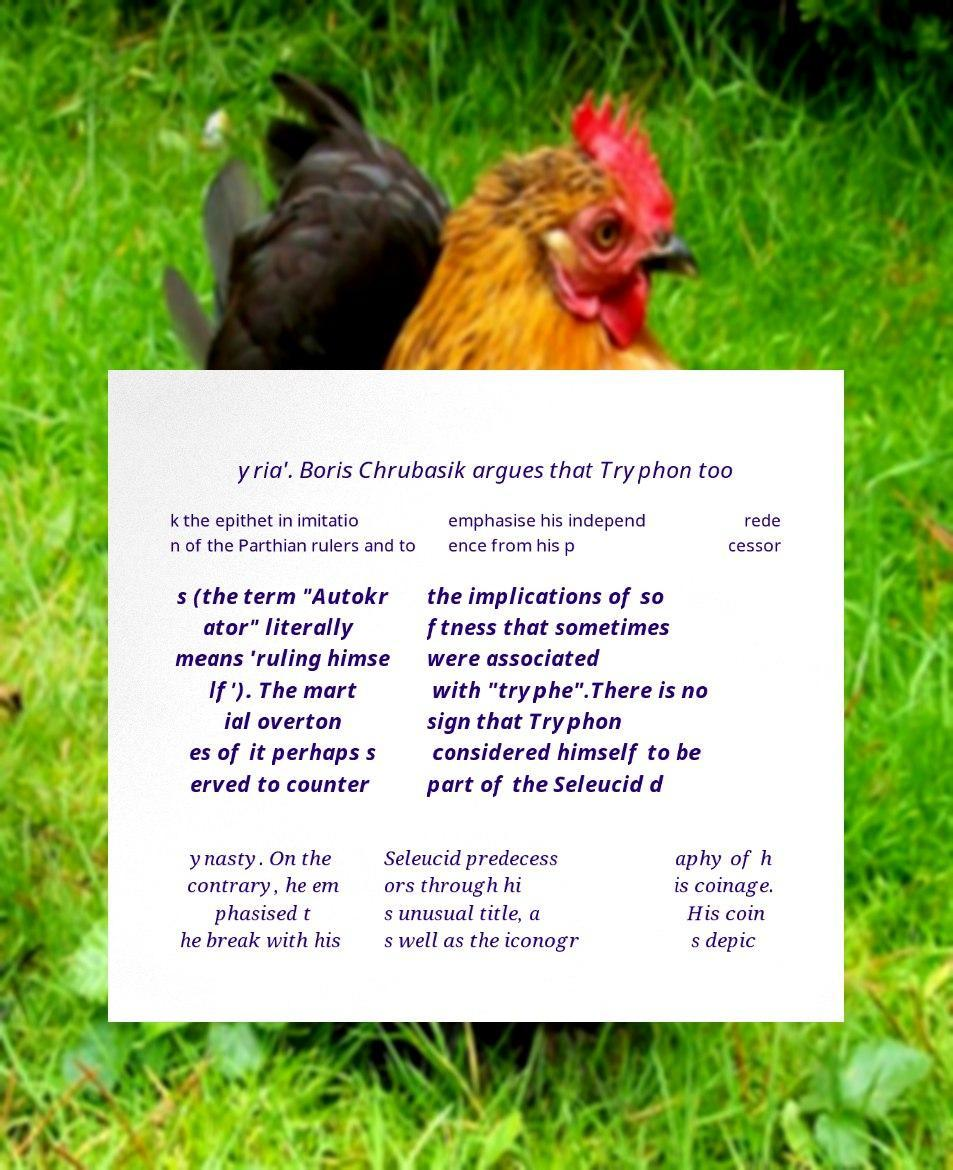Please identify and transcribe the text found in this image. yria'. Boris Chrubasik argues that Tryphon too k the epithet in imitatio n of the Parthian rulers and to emphasise his independ ence from his p rede cessor s (the term "Autokr ator" literally means 'ruling himse lf'). The mart ial overton es of it perhaps s erved to counter the implications of so ftness that sometimes were associated with "tryphe".There is no sign that Tryphon considered himself to be part of the Seleucid d ynasty. On the contrary, he em phasised t he break with his Seleucid predecess ors through hi s unusual title, a s well as the iconogr aphy of h is coinage. His coin s depic 